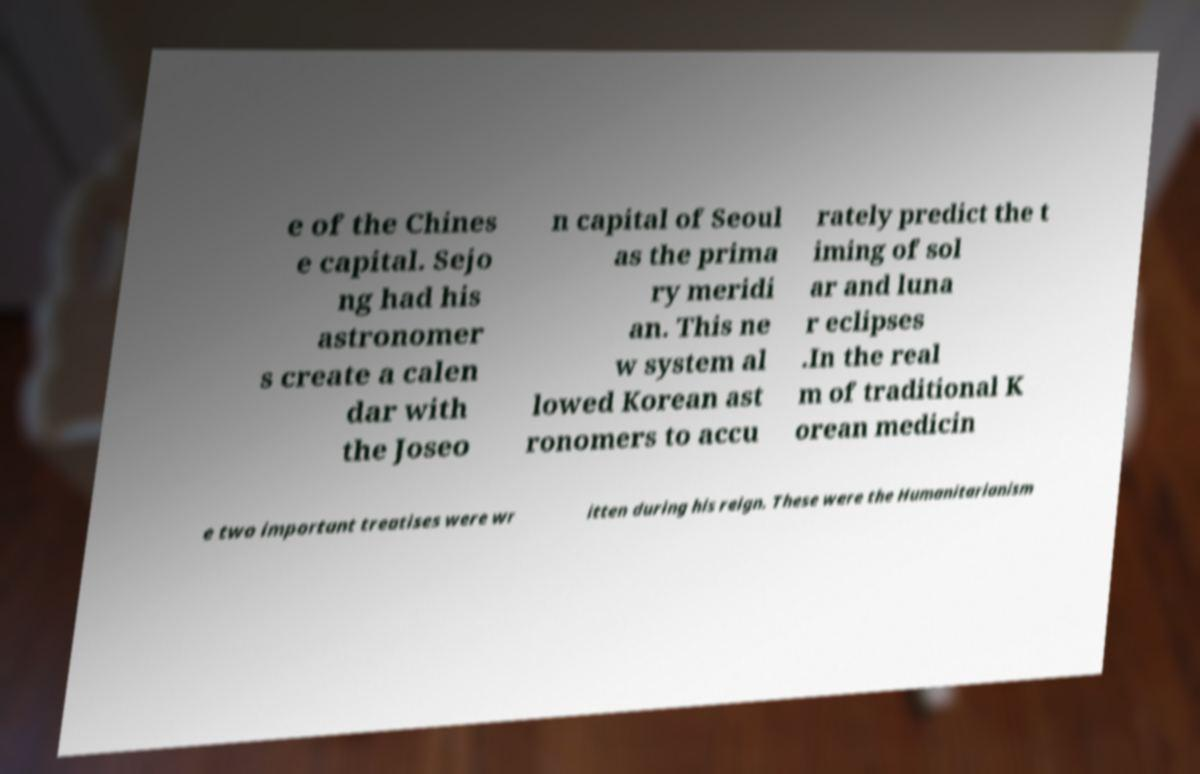Can you read and provide the text displayed in the image?This photo seems to have some interesting text. Can you extract and type it out for me? e of the Chines e capital. Sejo ng had his astronomer s create a calen dar with the Joseo n capital of Seoul as the prima ry meridi an. This ne w system al lowed Korean ast ronomers to accu rately predict the t iming of sol ar and luna r eclipses .In the real m of traditional K orean medicin e two important treatises were wr itten during his reign. These were the Humanitarianism 